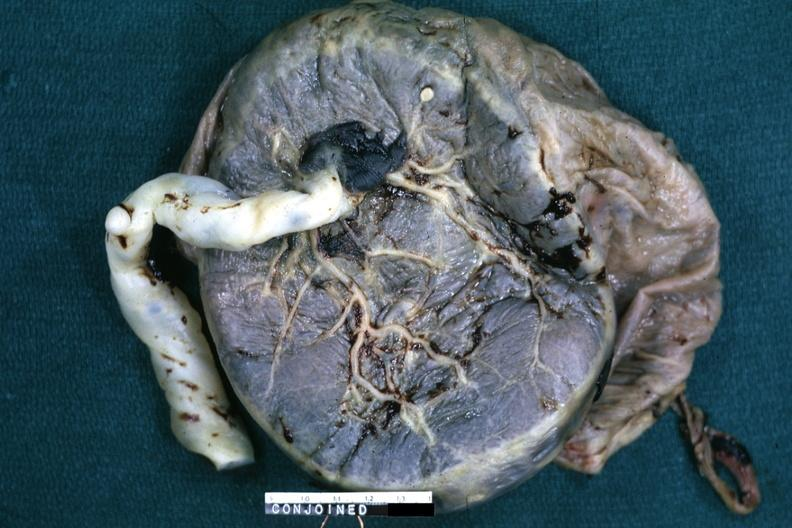does this image show fixed tissue single placenta with very large cord?
Answer the question using a single word or phrase. Yes 